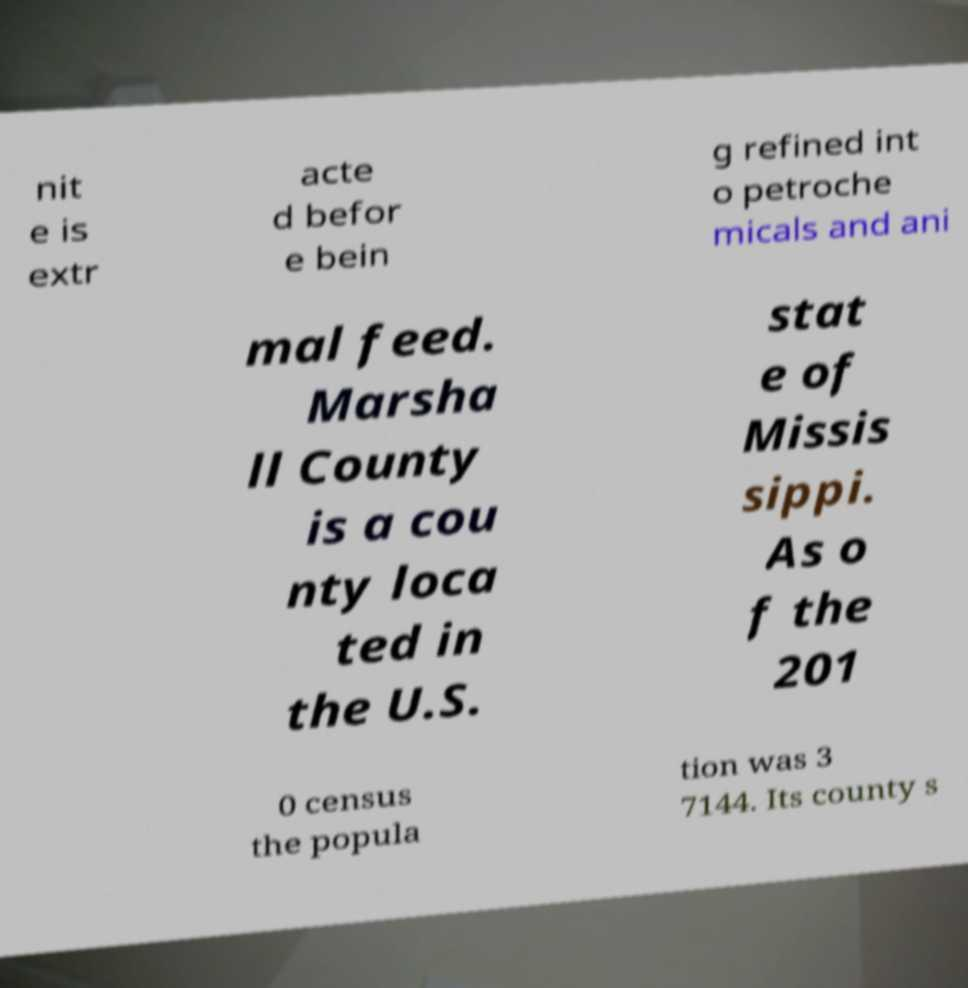Could you extract and type out the text from this image? nit e is extr acte d befor e bein g refined int o petroche micals and ani mal feed. Marsha ll County is a cou nty loca ted in the U.S. stat e of Missis sippi. As o f the 201 0 census the popula tion was 3 7144. Its county s 